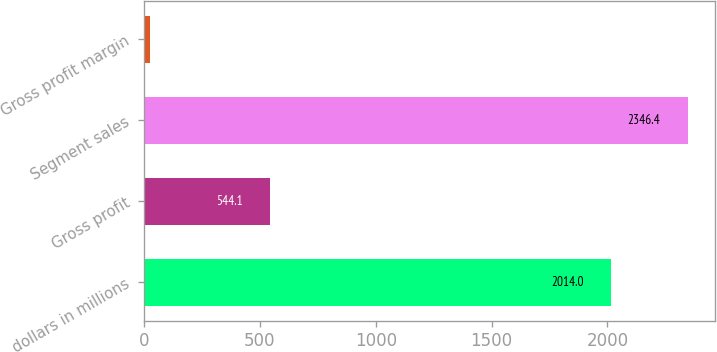<chart> <loc_0><loc_0><loc_500><loc_500><bar_chart><fcel>dollars in millions<fcel>Gross profit<fcel>Segment sales<fcel>Gross profit margin<nl><fcel>2014<fcel>544.1<fcel>2346.4<fcel>23.2<nl></chart> 